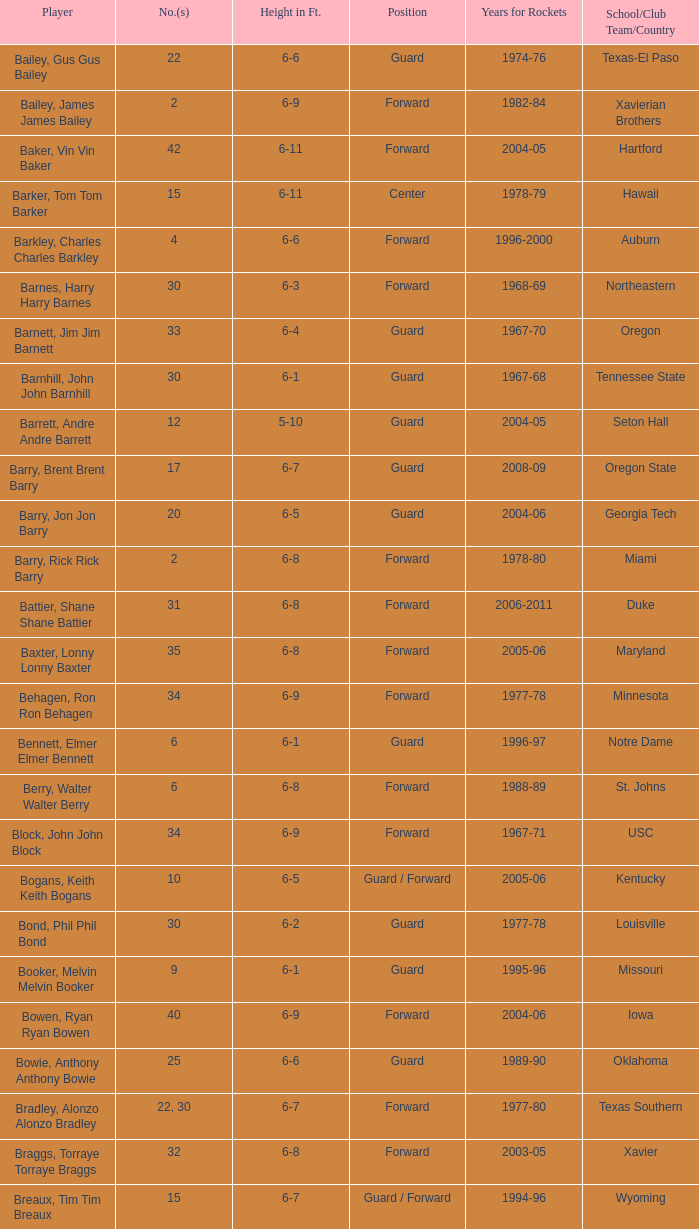What years was the participant from lasalle active for the rockets? 1982-83. 